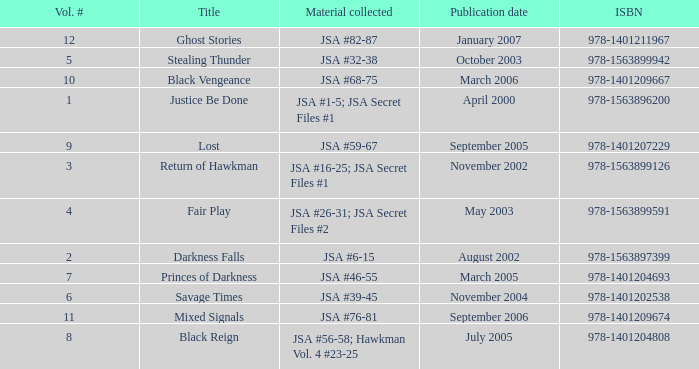Would you be able to parse every entry in this table? {'header': ['Vol. #', 'Title', 'Material collected', 'Publication date', 'ISBN'], 'rows': [['12', 'Ghost Stories', 'JSA #82-87', 'January 2007', '978-1401211967'], ['5', 'Stealing Thunder', 'JSA #32-38', 'October 2003', '978-1563899942'], ['10', 'Black Vengeance', 'JSA #68-75', 'March 2006', '978-1401209667'], ['1', 'Justice Be Done', 'JSA #1-5; JSA Secret Files #1', 'April 2000', '978-1563896200'], ['9', 'Lost', 'JSA #59-67', 'September 2005', '978-1401207229'], ['3', 'Return of Hawkman', 'JSA #16-25; JSA Secret Files #1', 'November 2002', '978-1563899126'], ['4', 'Fair Play', 'JSA #26-31; JSA Secret Files #2', 'May 2003', '978-1563899591'], ['2', 'Darkness Falls', 'JSA #6-15', 'August 2002', '978-1563897399'], ['7', 'Princes of Darkness', 'JSA #46-55', 'March 2005', '978-1401204693'], ['6', 'Savage Times', 'JSA #39-45', 'November 2004', '978-1401202538'], ['11', 'Mixed Signals', 'JSA #76-81', 'September 2006', '978-1401209674'], ['8', 'Black Reign', 'JSA #56-58; Hawkman Vol. 4 #23-25', 'July 2005', '978-1401204808']]} What's the Material collected for the 978-1401209674 ISBN? JSA #76-81. 